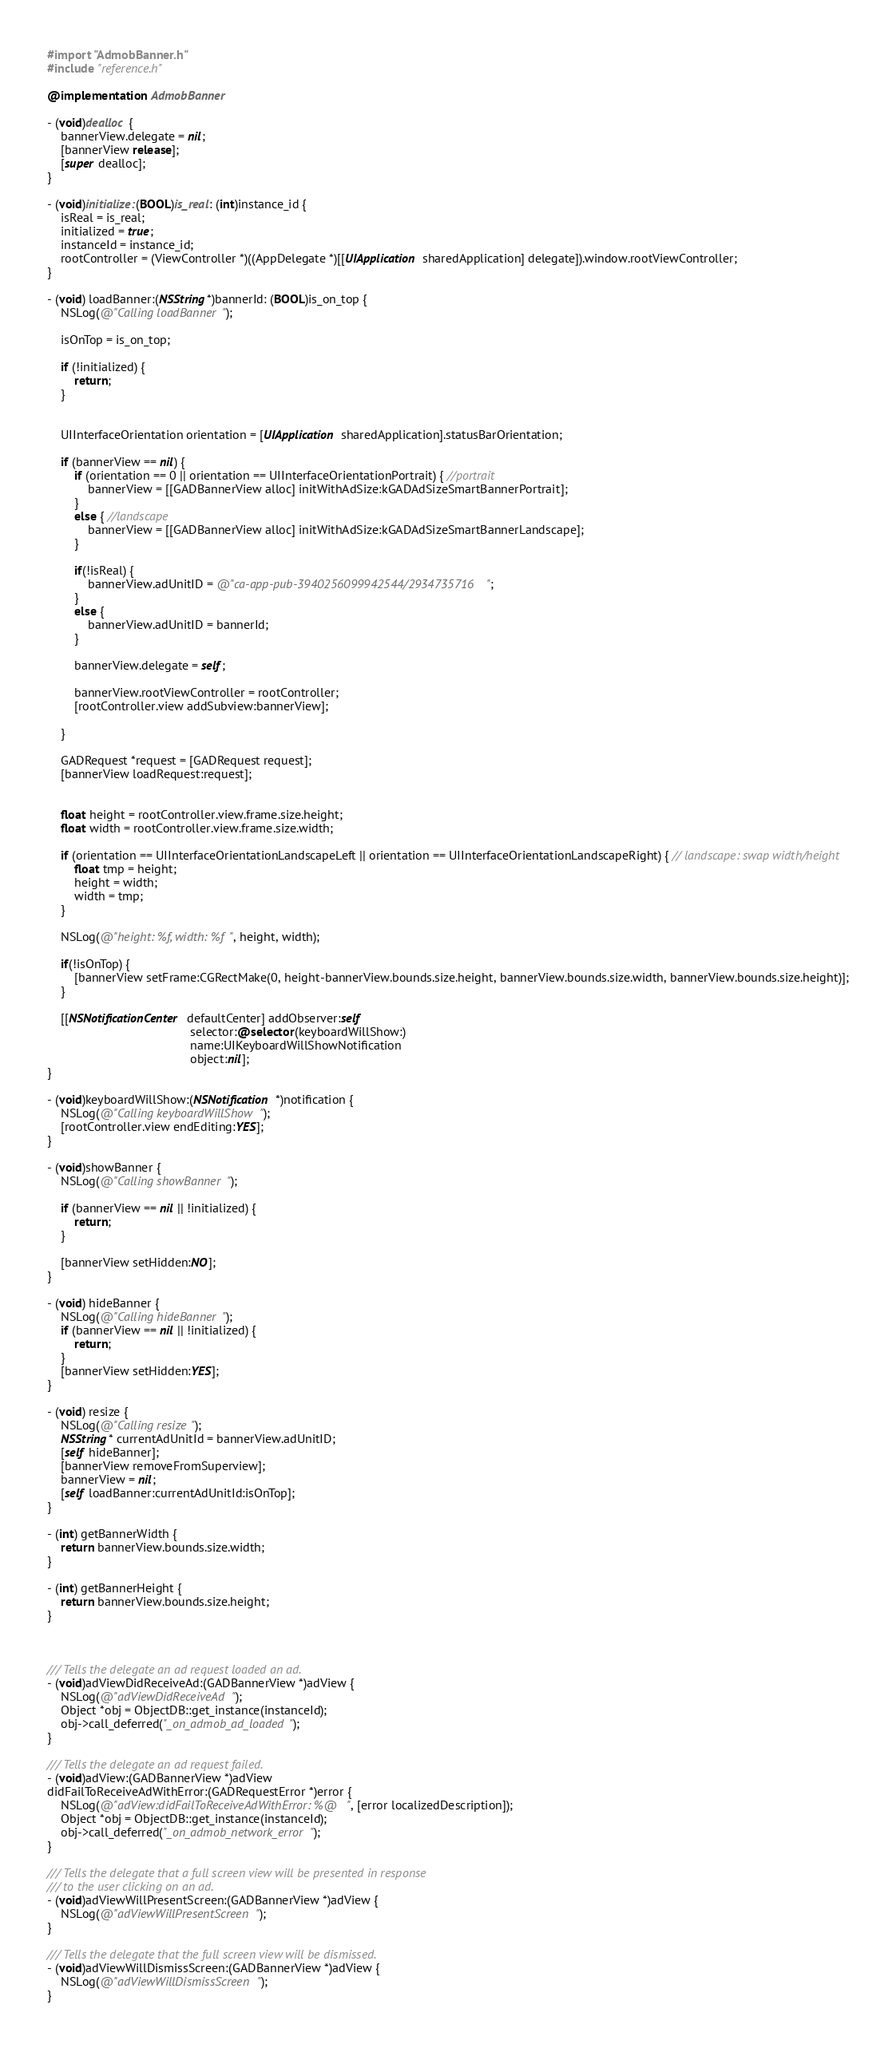Convert code to text. <code><loc_0><loc_0><loc_500><loc_500><_ObjectiveC_>#import "AdmobBanner.h"
#include "reference.h"

@implementation AdmobBanner

- (void)dealloc {
    bannerView.delegate = nil;
    [bannerView release];
    [super dealloc];
}

- (void)initialize:(BOOL)is_real: (int)instance_id {
    isReal = is_real;
    initialized = true;
    instanceId = instance_id;
    rootController = (ViewController *)((AppDelegate *)[[UIApplication sharedApplication] delegate]).window.rootViewController;
}

- (void) loadBanner:(NSString*)bannerId: (BOOL)is_on_top {
    NSLog(@"Calling loadBanner");
    
    isOnTop = is_on_top;
    
    if (!initialized) {
        return;
    }
    

    UIInterfaceOrientation orientation = [UIApplication sharedApplication].statusBarOrientation;
    
    if (bannerView == nil) {
        if (orientation == 0 || orientation == UIInterfaceOrientationPortrait) { //portrait
            bannerView = [[GADBannerView alloc] initWithAdSize:kGADAdSizeSmartBannerPortrait];
        }
        else { //landscape
            bannerView = [[GADBannerView alloc] initWithAdSize:kGADAdSizeSmartBannerLandscape];
        }
        
        if(!isReal) {
            bannerView.adUnitID = @"ca-app-pub-3940256099942544/2934735716";
        }
        else {
            bannerView.adUnitID = bannerId;
        }

        bannerView.delegate = self;
        
        bannerView.rootViewController = rootController;
        [rootController.view addSubview:bannerView];
        
    }
    
    GADRequest *request = [GADRequest request];
    [bannerView loadRequest:request];
    
    
    float height = rootController.view.frame.size.height;
    float width = rootController.view.frame.size.width;
    
    if (orientation == UIInterfaceOrientationLandscapeLeft || orientation == UIInterfaceOrientationLandscapeRight) { // landscape: swap width/height
        float tmp = height;
        height = width;
        width = tmp;
    }
    
    NSLog(@"height: %f, width: %f", height, width);

    if(!isOnTop) {
        [bannerView setFrame:CGRectMake(0, height-bannerView.bounds.size.height, bannerView.bounds.size.width, bannerView.bounds.size.height)];
    }

    [[NSNotificationCenter defaultCenter] addObserver:self
                                          selector:@selector(keyboardWillShow:)
                                          name:UIKeyboardWillShowNotification
                                          object:nil];
}

- (void)keyboardWillShow:(NSNotification *)notification {
	NSLog(@"Calling keyboardWillShow");
	[rootController.view endEditing:YES];
}

- (void)showBanner {
    NSLog(@"Calling showBanner");
    
    if (bannerView == nil || !initialized) {
        return;
    }
    
    [bannerView setHidden:NO];
}

- (void) hideBanner {
    NSLog(@"Calling hideBanner");
    if (bannerView == nil || !initialized) {
        return;
    }
    [bannerView setHidden:YES];
}

- (void) resize {
    NSLog(@"Calling resize");
    NSString* currentAdUnitId = bannerView.adUnitID;
    [self hideBanner];
    [bannerView removeFromSuperview];
    bannerView = nil;
    [self loadBanner:currentAdUnitId:isOnTop];
}

- (int) getBannerWidth {
    return bannerView.bounds.size.width;
}

- (int) getBannerHeight {
    return bannerView.bounds.size.height;
}



/// Tells the delegate an ad request loaded an ad.
- (void)adViewDidReceiveAd:(GADBannerView *)adView {
    NSLog(@"adViewDidReceiveAd");
    Object *obj = ObjectDB::get_instance(instanceId);
    obj->call_deferred("_on_admob_ad_loaded");
}

/// Tells the delegate an ad request failed.
- (void)adView:(GADBannerView *)adView
didFailToReceiveAdWithError:(GADRequestError *)error {
    NSLog(@"adView:didFailToReceiveAdWithError: %@", [error localizedDescription]);
    Object *obj = ObjectDB::get_instance(instanceId);
    obj->call_deferred("_on_admob_network_error");
}

/// Tells the delegate that a full screen view will be presented in response
/// to the user clicking on an ad.
- (void)adViewWillPresentScreen:(GADBannerView *)adView {
    NSLog(@"adViewWillPresentScreen");
}

/// Tells the delegate that the full screen view will be dismissed.
- (void)adViewWillDismissScreen:(GADBannerView *)adView {
    NSLog(@"adViewWillDismissScreen");
}
</code> 